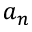Convert formula to latex. <formula><loc_0><loc_0><loc_500><loc_500>a _ { n }</formula> 